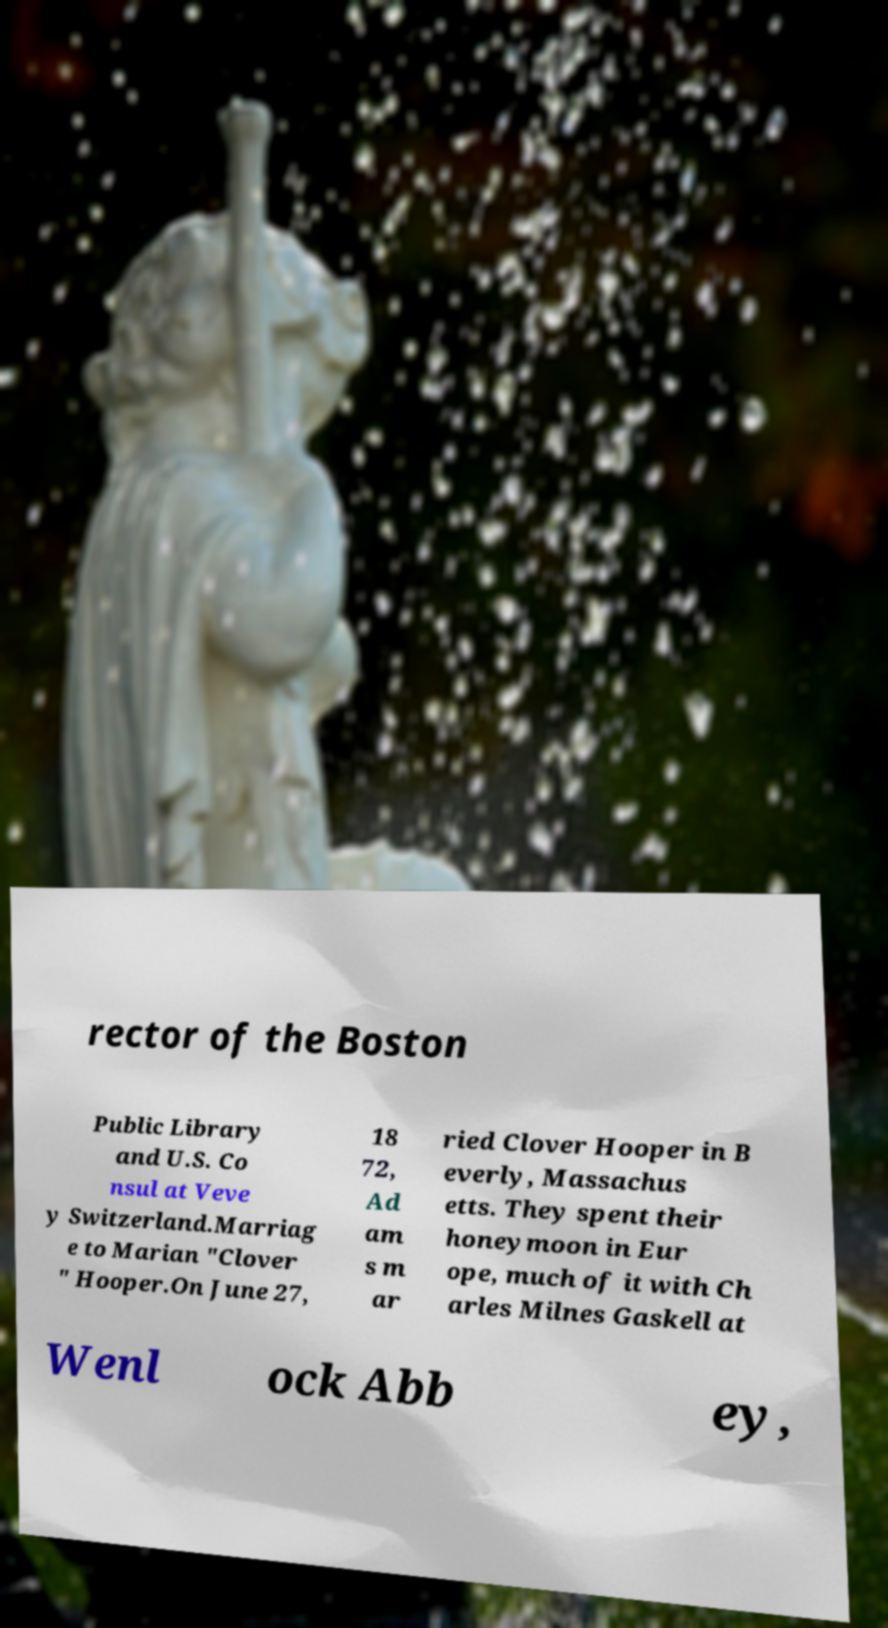For documentation purposes, I need the text within this image transcribed. Could you provide that? rector of the Boston Public Library and U.S. Co nsul at Veve y Switzerland.Marriag e to Marian "Clover " Hooper.On June 27, 18 72, Ad am s m ar ried Clover Hooper in B everly, Massachus etts. They spent their honeymoon in Eur ope, much of it with Ch arles Milnes Gaskell at Wenl ock Abb ey, 